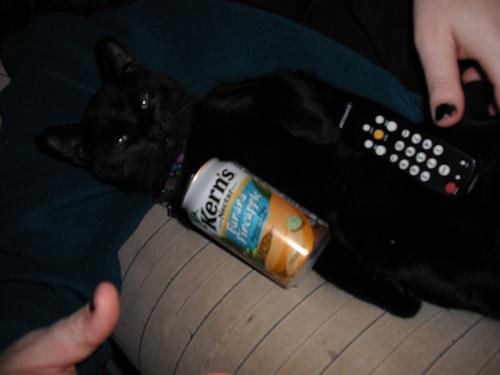How many people are in the photo?
Give a very brief answer. 2. 